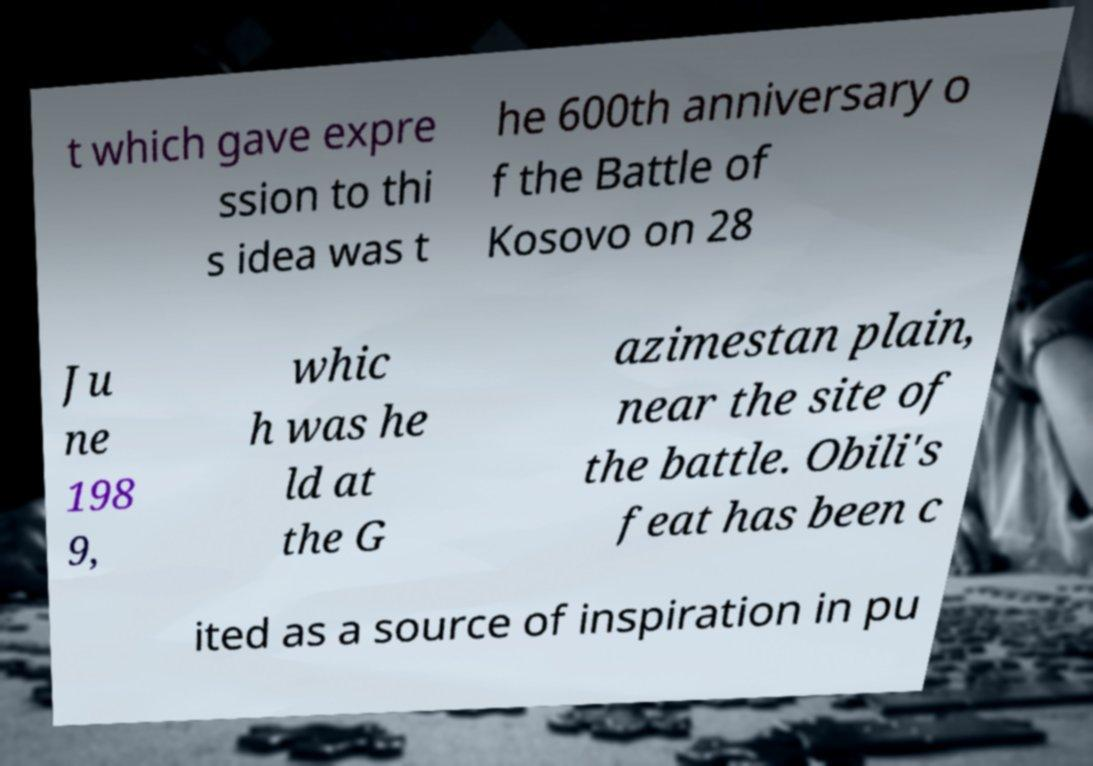Could you extract and type out the text from this image? t which gave expre ssion to thi s idea was t he 600th anniversary o f the Battle of Kosovo on 28 Ju ne 198 9, whic h was he ld at the G azimestan plain, near the site of the battle. Obili's feat has been c ited as a source of inspiration in pu 